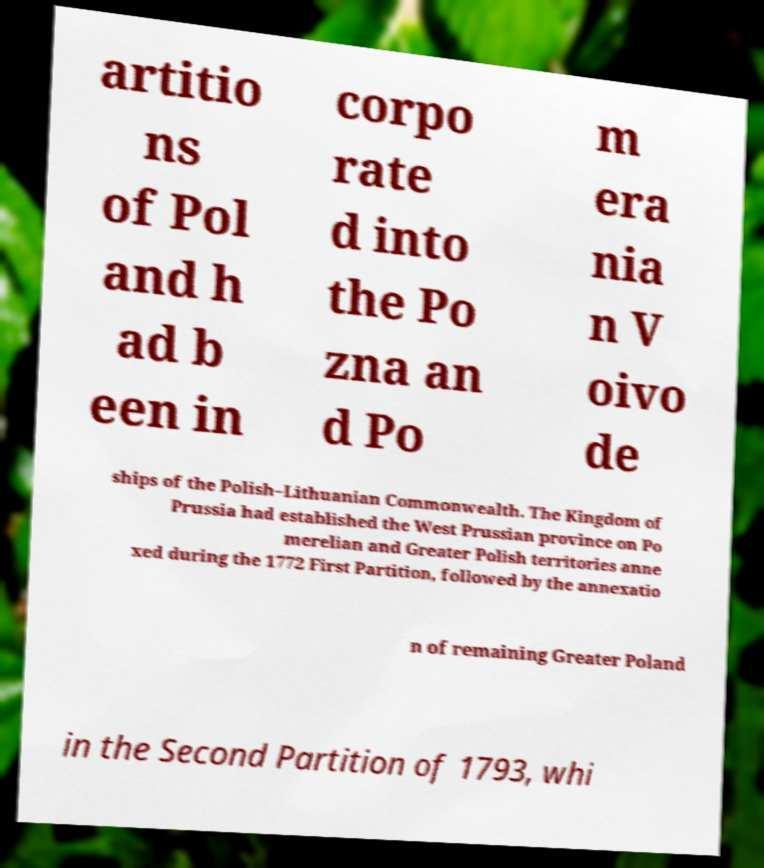Could you assist in decoding the text presented in this image and type it out clearly? artitio ns of Pol and h ad b een in corpo rate d into the Po zna an d Po m era nia n V oivo de ships of the Polish–Lithuanian Commonwealth. The Kingdom of Prussia had established the West Prussian province on Po merelian and Greater Polish territories anne xed during the 1772 First Partition, followed by the annexatio n of remaining Greater Poland in the Second Partition of 1793, whi 